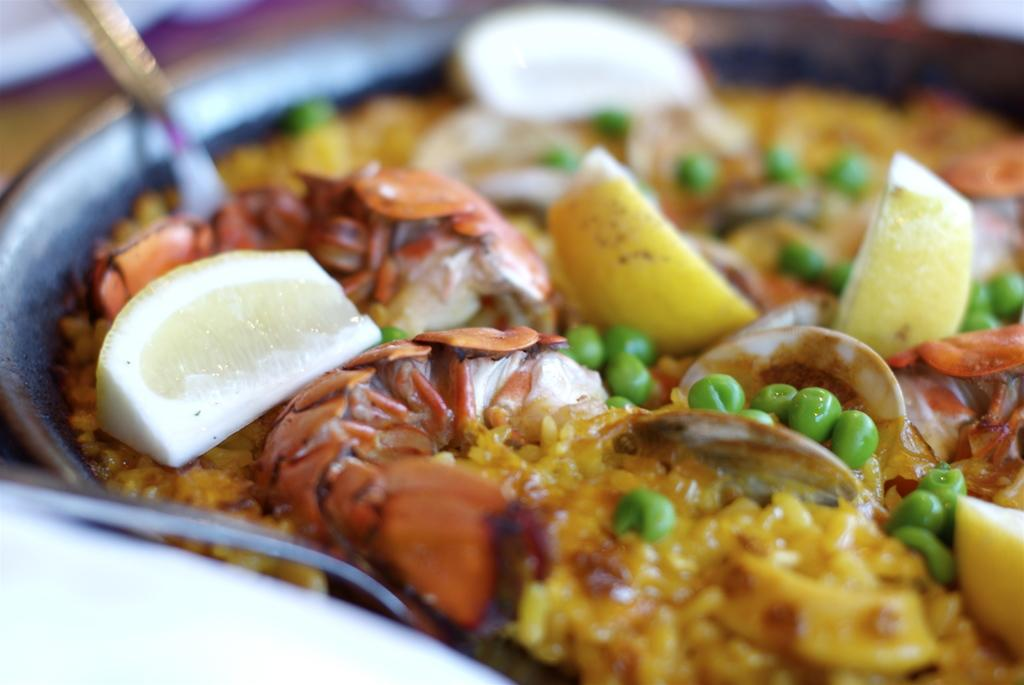What type of food item is in the image? There is a food item in the image, but the specific type cannot be determined due to the blur. What utensil is present in the image? There is a spoon in the plate in the image. What can be seen on the food item? There are lemon slices on the food item. How is the image affected by blur? The top and left side of the image are blurred, but objects are still visible despite the blur. What type of jar is visible in the image? There is no jar present in the image. How does the earthquake affect the food item in the image? There is no earthquake depicted in the image, so its effect on the food item cannot be determined. 